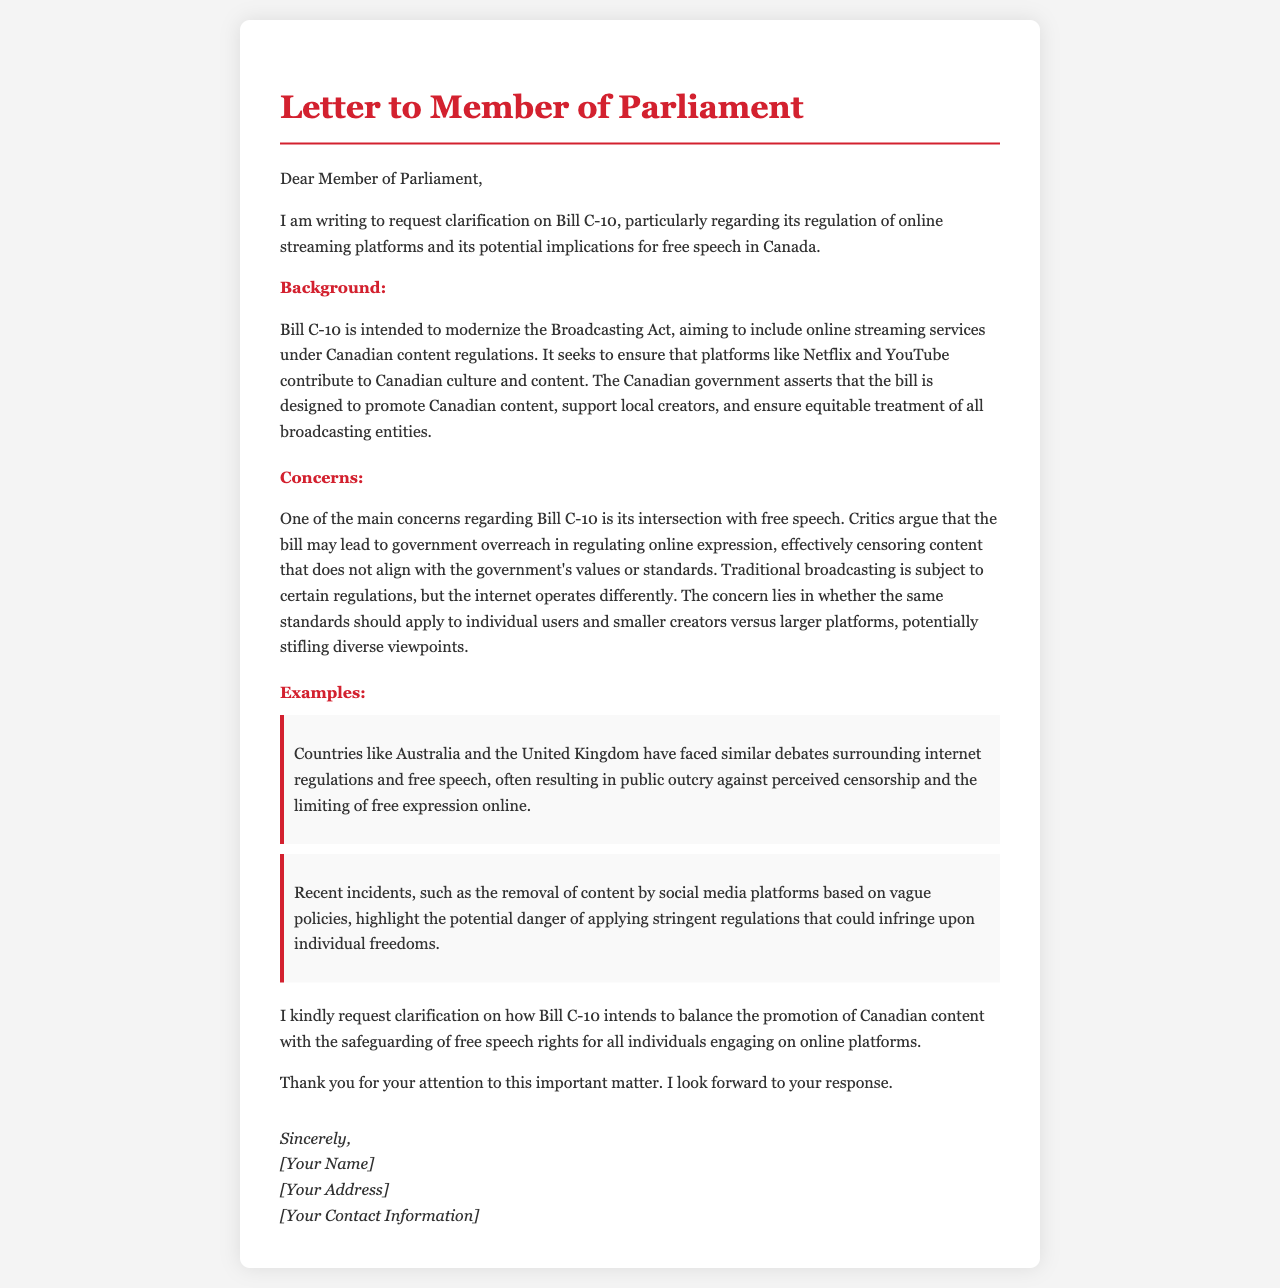What is the title of the bill discussed in the letter? The title of the bill is explicitly mentioned as Bill C-10 in the document.
Answer: Bill C-10 What is the primary objective of Bill C-10? The primary objective of Bill C-10 is to modernize the Broadcasting Act, which is stated in the background section of the letter.
Answer: Modernize the Broadcasting Act Which platforms are primarily targeted by Bill C-10? The platforms specifically mentioned as being included under the bill's regulation are Netflix and YouTube.
Answer: Netflix and YouTube What is a major concern raised about Bill C-10? The major concern highlighted in the letter is the potential government overreach in regulating online expression.
Answer: Government overreach What example is given to illustrate the debate around internet regulations? The letter references debates in countries like Australia and the United Kingdom concerning internet regulations and free speech.
Answer: Australia and the United Kingdom What does the author request clarification on regarding Bill C-10? The author requests clarification on how the bill intends to balance Canadian content promotion with free speech rights.
Answer: Balance of Canadian content and free speech Who is the letter addressed to? The letter is addressed to a generic Member of Parliament, as identified in the salutation.
Answer: Member of Parliament What is included in the signature section? The signature section contains the author's name, address, and contact information.
Answer: Author's name, address, and contact information 